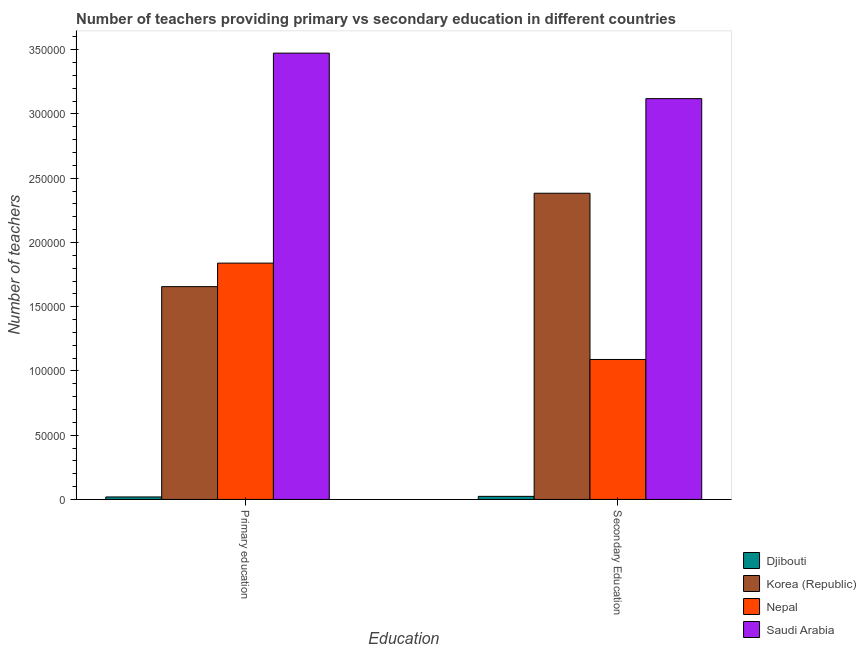Are the number of bars per tick equal to the number of legend labels?
Ensure brevity in your answer.  Yes. Are the number of bars on each tick of the X-axis equal?
Your answer should be very brief. Yes. How many bars are there on the 1st tick from the right?
Offer a terse response. 4. What is the label of the 1st group of bars from the left?
Provide a short and direct response. Primary education. What is the number of primary teachers in Saudi Arabia?
Offer a very short reply. 3.47e+05. Across all countries, what is the maximum number of secondary teachers?
Provide a succinct answer. 3.12e+05. Across all countries, what is the minimum number of primary teachers?
Give a very brief answer. 1935. In which country was the number of secondary teachers maximum?
Your answer should be compact. Saudi Arabia. In which country was the number of secondary teachers minimum?
Your response must be concise. Djibouti. What is the total number of primary teachers in the graph?
Offer a terse response. 6.99e+05. What is the difference between the number of secondary teachers in Saudi Arabia and that in Korea (Republic)?
Your answer should be very brief. 7.36e+04. What is the difference between the number of secondary teachers in Nepal and the number of primary teachers in Korea (Republic)?
Make the answer very short. -5.67e+04. What is the average number of primary teachers per country?
Keep it short and to the point. 1.75e+05. What is the difference between the number of primary teachers and number of secondary teachers in Saudi Arabia?
Provide a short and direct response. 3.54e+04. In how many countries, is the number of secondary teachers greater than 90000 ?
Offer a terse response. 3. What is the ratio of the number of secondary teachers in Nepal to that in Djibouti?
Offer a very short reply. 45.65. Is the number of secondary teachers in Nepal less than that in Saudi Arabia?
Provide a short and direct response. Yes. In how many countries, is the number of primary teachers greater than the average number of primary teachers taken over all countries?
Keep it short and to the point. 2. What does the 1st bar from the left in Primary education represents?
Your answer should be compact. Djibouti. How many bars are there?
Your answer should be compact. 8. Does the graph contain any zero values?
Your response must be concise. No. How are the legend labels stacked?
Keep it short and to the point. Vertical. What is the title of the graph?
Offer a terse response. Number of teachers providing primary vs secondary education in different countries. Does "Hong Kong" appear as one of the legend labels in the graph?
Offer a very short reply. No. What is the label or title of the X-axis?
Provide a succinct answer. Education. What is the label or title of the Y-axis?
Your answer should be compact. Number of teachers. What is the Number of teachers of Djibouti in Primary education?
Provide a succinct answer. 1935. What is the Number of teachers of Korea (Republic) in Primary education?
Make the answer very short. 1.66e+05. What is the Number of teachers of Nepal in Primary education?
Provide a short and direct response. 1.84e+05. What is the Number of teachers of Saudi Arabia in Primary education?
Keep it short and to the point. 3.47e+05. What is the Number of teachers in Djibouti in Secondary Education?
Give a very brief answer. 2386. What is the Number of teachers of Korea (Republic) in Secondary Education?
Your answer should be compact. 2.38e+05. What is the Number of teachers in Nepal in Secondary Education?
Provide a succinct answer. 1.09e+05. What is the Number of teachers of Saudi Arabia in Secondary Education?
Offer a very short reply. 3.12e+05. Across all Education, what is the maximum Number of teachers in Djibouti?
Ensure brevity in your answer.  2386. Across all Education, what is the maximum Number of teachers of Korea (Republic)?
Keep it short and to the point. 2.38e+05. Across all Education, what is the maximum Number of teachers in Nepal?
Offer a very short reply. 1.84e+05. Across all Education, what is the maximum Number of teachers of Saudi Arabia?
Keep it short and to the point. 3.47e+05. Across all Education, what is the minimum Number of teachers in Djibouti?
Provide a short and direct response. 1935. Across all Education, what is the minimum Number of teachers in Korea (Republic)?
Make the answer very short. 1.66e+05. Across all Education, what is the minimum Number of teachers of Nepal?
Offer a very short reply. 1.09e+05. Across all Education, what is the minimum Number of teachers in Saudi Arabia?
Offer a very short reply. 3.12e+05. What is the total Number of teachers in Djibouti in the graph?
Your answer should be compact. 4321. What is the total Number of teachers of Korea (Republic) in the graph?
Your response must be concise. 4.04e+05. What is the total Number of teachers of Nepal in the graph?
Ensure brevity in your answer.  2.93e+05. What is the total Number of teachers of Saudi Arabia in the graph?
Provide a short and direct response. 6.59e+05. What is the difference between the Number of teachers of Djibouti in Primary education and that in Secondary Education?
Your response must be concise. -451. What is the difference between the Number of teachers in Korea (Republic) in Primary education and that in Secondary Education?
Your answer should be very brief. -7.27e+04. What is the difference between the Number of teachers of Nepal in Primary education and that in Secondary Education?
Your answer should be very brief. 7.50e+04. What is the difference between the Number of teachers in Saudi Arabia in Primary education and that in Secondary Education?
Make the answer very short. 3.54e+04. What is the difference between the Number of teachers of Djibouti in Primary education and the Number of teachers of Korea (Republic) in Secondary Education?
Give a very brief answer. -2.36e+05. What is the difference between the Number of teachers in Djibouti in Primary education and the Number of teachers in Nepal in Secondary Education?
Keep it short and to the point. -1.07e+05. What is the difference between the Number of teachers in Djibouti in Primary education and the Number of teachers in Saudi Arabia in Secondary Education?
Make the answer very short. -3.10e+05. What is the difference between the Number of teachers in Korea (Republic) in Primary education and the Number of teachers in Nepal in Secondary Education?
Your response must be concise. 5.67e+04. What is the difference between the Number of teachers of Korea (Republic) in Primary education and the Number of teachers of Saudi Arabia in Secondary Education?
Your answer should be compact. -1.46e+05. What is the difference between the Number of teachers in Nepal in Primary education and the Number of teachers in Saudi Arabia in Secondary Education?
Provide a succinct answer. -1.28e+05. What is the average Number of teachers in Djibouti per Education?
Make the answer very short. 2160.5. What is the average Number of teachers in Korea (Republic) per Education?
Make the answer very short. 2.02e+05. What is the average Number of teachers of Nepal per Education?
Give a very brief answer. 1.46e+05. What is the average Number of teachers in Saudi Arabia per Education?
Offer a terse response. 3.30e+05. What is the difference between the Number of teachers in Djibouti and Number of teachers in Korea (Republic) in Primary education?
Provide a short and direct response. -1.64e+05. What is the difference between the Number of teachers of Djibouti and Number of teachers of Nepal in Primary education?
Offer a very short reply. -1.82e+05. What is the difference between the Number of teachers in Djibouti and Number of teachers in Saudi Arabia in Primary education?
Your answer should be compact. -3.45e+05. What is the difference between the Number of teachers in Korea (Republic) and Number of teachers in Nepal in Primary education?
Your answer should be very brief. -1.83e+04. What is the difference between the Number of teachers in Korea (Republic) and Number of teachers in Saudi Arabia in Primary education?
Your answer should be compact. -1.82e+05. What is the difference between the Number of teachers of Nepal and Number of teachers of Saudi Arabia in Primary education?
Make the answer very short. -1.63e+05. What is the difference between the Number of teachers of Djibouti and Number of teachers of Korea (Republic) in Secondary Education?
Provide a short and direct response. -2.36e+05. What is the difference between the Number of teachers of Djibouti and Number of teachers of Nepal in Secondary Education?
Provide a succinct answer. -1.07e+05. What is the difference between the Number of teachers of Djibouti and Number of teachers of Saudi Arabia in Secondary Education?
Provide a short and direct response. -3.10e+05. What is the difference between the Number of teachers in Korea (Republic) and Number of teachers in Nepal in Secondary Education?
Your response must be concise. 1.29e+05. What is the difference between the Number of teachers in Korea (Republic) and Number of teachers in Saudi Arabia in Secondary Education?
Ensure brevity in your answer.  -7.36e+04. What is the difference between the Number of teachers of Nepal and Number of teachers of Saudi Arabia in Secondary Education?
Keep it short and to the point. -2.03e+05. What is the ratio of the Number of teachers in Djibouti in Primary education to that in Secondary Education?
Provide a short and direct response. 0.81. What is the ratio of the Number of teachers in Korea (Republic) in Primary education to that in Secondary Education?
Give a very brief answer. 0.69. What is the ratio of the Number of teachers in Nepal in Primary education to that in Secondary Education?
Your answer should be compact. 1.69. What is the ratio of the Number of teachers of Saudi Arabia in Primary education to that in Secondary Education?
Offer a very short reply. 1.11. What is the difference between the highest and the second highest Number of teachers of Djibouti?
Provide a succinct answer. 451. What is the difference between the highest and the second highest Number of teachers in Korea (Republic)?
Give a very brief answer. 7.27e+04. What is the difference between the highest and the second highest Number of teachers in Nepal?
Make the answer very short. 7.50e+04. What is the difference between the highest and the second highest Number of teachers of Saudi Arabia?
Give a very brief answer. 3.54e+04. What is the difference between the highest and the lowest Number of teachers of Djibouti?
Your response must be concise. 451. What is the difference between the highest and the lowest Number of teachers in Korea (Republic)?
Keep it short and to the point. 7.27e+04. What is the difference between the highest and the lowest Number of teachers in Nepal?
Your response must be concise. 7.50e+04. What is the difference between the highest and the lowest Number of teachers in Saudi Arabia?
Make the answer very short. 3.54e+04. 